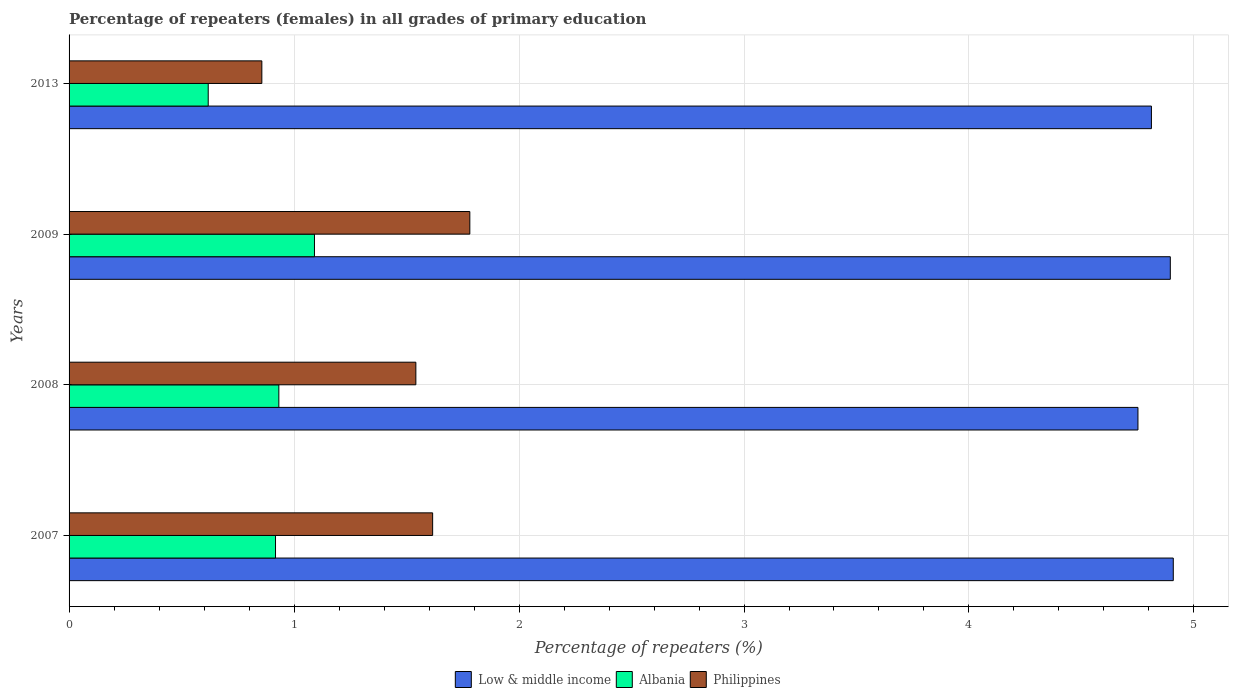How many groups of bars are there?
Provide a succinct answer. 4. How many bars are there on the 3rd tick from the top?
Offer a terse response. 3. How many bars are there on the 1st tick from the bottom?
Make the answer very short. 3. What is the percentage of repeaters (females) in Philippines in 2007?
Offer a very short reply. 1.62. Across all years, what is the maximum percentage of repeaters (females) in Low & middle income?
Provide a succinct answer. 4.91. Across all years, what is the minimum percentage of repeaters (females) in Low & middle income?
Provide a succinct answer. 4.75. In which year was the percentage of repeaters (females) in Philippines minimum?
Offer a terse response. 2013. What is the total percentage of repeaters (females) in Low & middle income in the graph?
Offer a terse response. 19.37. What is the difference between the percentage of repeaters (females) in Low & middle income in 2009 and that in 2013?
Provide a short and direct response. 0.08. What is the difference between the percentage of repeaters (females) in Philippines in 2007 and the percentage of repeaters (females) in Low & middle income in 2013?
Offer a very short reply. -3.19. What is the average percentage of repeaters (females) in Albania per year?
Provide a short and direct response. 0.89. In the year 2007, what is the difference between the percentage of repeaters (females) in Low & middle income and percentage of repeaters (females) in Philippines?
Make the answer very short. 3.29. What is the ratio of the percentage of repeaters (females) in Albania in 2007 to that in 2008?
Your answer should be compact. 0.98. Is the percentage of repeaters (females) in Albania in 2007 less than that in 2008?
Keep it short and to the point. Yes. What is the difference between the highest and the second highest percentage of repeaters (females) in Albania?
Make the answer very short. 0.16. What is the difference between the highest and the lowest percentage of repeaters (females) in Low & middle income?
Ensure brevity in your answer.  0.16. Is it the case that in every year, the sum of the percentage of repeaters (females) in Low & middle income and percentage of repeaters (females) in Albania is greater than the percentage of repeaters (females) in Philippines?
Offer a terse response. Yes. How many years are there in the graph?
Ensure brevity in your answer.  4. What is the difference between two consecutive major ticks on the X-axis?
Offer a very short reply. 1. Are the values on the major ticks of X-axis written in scientific E-notation?
Make the answer very short. No. Does the graph contain any zero values?
Provide a short and direct response. No. Where does the legend appear in the graph?
Provide a short and direct response. Bottom center. How many legend labels are there?
Your response must be concise. 3. How are the legend labels stacked?
Offer a terse response. Horizontal. What is the title of the graph?
Provide a succinct answer. Percentage of repeaters (females) in all grades of primary education. What is the label or title of the X-axis?
Give a very brief answer. Percentage of repeaters (%). What is the label or title of the Y-axis?
Offer a terse response. Years. What is the Percentage of repeaters (%) of Low & middle income in 2007?
Provide a succinct answer. 4.91. What is the Percentage of repeaters (%) in Albania in 2007?
Your answer should be very brief. 0.92. What is the Percentage of repeaters (%) in Philippines in 2007?
Offer a terse response. 1.62. What is the Percentage of repeaters (%) of Low & middle income in 2008?
Provide a succinct answer. 4.75. What is the Percentage of repeaters (%) of Albania in 2008?
Ensure brevity in your answer.  0.93. What is the Percentage of repeaters (%) of Philippines in 2008?
Make the answer very short. 1.54. What is the Percentage of repeaters (%) in Low & middle income in 2009?
Provide a succinct answer. 4.89. What is the Percentage of repeaters (%) in Albania in 2009?
Give a very brief answer. 1.09. What is the Percentage of repeaters (%) in Philippines in 2009?
Provide a short and direct response. 1.78. What is the Percentage of repeaters (%) in Low & middle income in 2013?
Offer a terse response. 4.81. What is the Percentage of repeaters (%) in Albania in 2013?
Offer a very short reply. 0.62. What is the Percentage of repeaters (%) of Philippines in 2013?
Offer a terse response. 0.86. Across all years, what is the maximum Percentage of repeaters (%) of Low & middle income?
Your answer should be very brief. 4.91. Across all years, what is the maximum Percentage of repeaters (%) in Albania?
Provide a succinct answer. 1.09. Across all years, what is the maximum Percentage of repeaters (%) of Philippines?
Provide a succinct answer. 1.78. Across all years, what is the minimum Percentage of repeaters (%) of Low & middle income?
Offer a terse response. 4.75. Across all years, what is the minimum Percentage of repeaters (%) in Albania?
Provide a succinct answer. 0.62. Across all years, what is the minimum Percentage of repeaters (%) in Philippines?
Keep it short and to the point. 0.86. What is the total Percentage of repeaters (%) of Low & middle income in the graph?
Provide a succinct answer. 19.37. What is the total Percentage of repeaters (%) of Albania in the graph?
Make the answer very short. 3.56. What is the total Percentage of repeaters (%) in Philippines in the graph?
Provide a short and direct response. 5.8. What is the difference between the Percentage of repeaters (%) in Low & middle income in 2007 and that in 2008?
Your answer should be very brief. 0.16. What is the difference between the Percentage of repeaters (%) in Albania in 2007 and that in 2008?
Provide a succinct answer. -0.01. What is the difference between the Percentage of repeaters (%) in Philippines in 2007 and that in 2008?
Provide a succinct answer. 0.07. What is the difference between the Percentage of repeaters (%) of Low & middle income in 2007 and that in 2009?
Provide a succinct answer. 0.01. What is the difference between the Percentage of repeaters (%) of Albania in 2007 and that in 2009?
Offer a very short reply. -0.17. What is the difference between the Percentage of repeaters (%) of Philippines in 2007 and that in 2009?
Your answer should be very brief. -0.17. What is the difference between the Percentage of repeaters (%) of Low & middle income in 2007 and that in 2013?
Make the answer very short. 0.1. What is the difference between the Percentage of repeaters (%) in Albania in 2007 and that in 2013?
Keep it short and to the point. 0.3. What is the difference between the Percentage of repeaters (%) in Philippines in 2007 and that in 2013?
Your answer should be very brief. 0.76. What is the difference between the Percentage of repeaters (%) of Low & middle income in 2008 and that in 2009?
Make the answer very short. -0.14. What is the difference between the Percentage of repeaters (%) in Albania in 2008 and that in 2009?
Give a very brief answer. -0.16. What is the difference between the Percentage of repeaters (%) in Philippines in 2008 and that in 2009?
Your answer should be very brief. -0.24. What is the difference between the Percentage of repeaters (%) in Low & middle income in 2008 and that in 2013?
Offer a very short reply. -0.06. What is the difference between the Percentage of repeaters (%) of Albania in 2008 and that in 2013?
Make the answer very short. 0.31. What is the difference between the Percentage of repeaters (%) of Philippines in 2008 and that in 2013?
Your answer should be very brief. 0.68. What is the difference between the Percentage of repeaters (%) in Low & middle income in 2009 and that in 2013?
Your response must be concise. 0.08. What is the difference between the Percentage of repeaters (%) of Albania in 2009 and that in 2013?
Your answer should be compact. 0.47. What is the difference between the Percentage of repeaters (%) in Philippines in 2009 and that in 2013?
Ensure brevity in your answer.  0.92. What is the difference between the Percentage of repeaters (%) of Low & middle income in 2007 and the Percentage of repeaters (%) of Albania in 2008?
Give a very brief answer. 3.98. What is the difference between the Percentage of repeaters (%) in Low & middle income in 2007 and the Percentage of repeaters (%) in Philippines in 2008?
Keep it short and to the point. 3.37. What is the difference between the Percentage of repeaters (%) in Albania in 2007 and the Percentage of repeaters (%) in Philippines in 2008?
Offer a very short reply. -0.62. What is the difference between the Percentage of repeaters (%) of Low & middle income in 2007 and the Percentage of repeaters (%) of Albania in 2009?
Offer a terse response. 3.82. What is the difference between the Percentage of repeaters (%) in Low & middle income in 2007 and the Percentage of repeaters (%) in Philippines in 2009?
Ensure brevity in your answer.  3.13. What is the difference between the Percentage of repeaters (%) in Albania in 2007 and the Percentage of repeaters (%) in Philippines in 2009?
Offer a terse response. -0.86. What is the difference between the Percentage of repeaters (%) in Low & middle income in 2007 and the Percentage of repeaters (%) in Albania in 2013?
Your response must be concise. 4.29. What is the difference between the Percentage of repeaters (%) in Low & middle income in 2007 and the Percentage of repeaters (%) in Philippines in 2013?
Give a very brief answer. 4.05. What is the difference between the Percentage of repeaters (%) of Albania in 2007 and the Percentage of repeaters (%) of Philippines in 2013?
Keep it short and to the point. 0.06. What is the difference between the Percentage of repeaters (%) of Low & middle income in 2008 and the Percentage of repeaters (%) of Albania in 2009?
Ensure brevity in your answer.  3.66. What is the difference between the Percentage of repeaters (%) of Low & middle income in 2008 and the Percentage of repeaters (%) of Philippines in 2009?
Make the answer very short. 2.97. What is the difference between the Percentage of repeaters (%) in Albania in 2008 and the Percentage of repeaters (%) in Philippines in 2009?
Make the answer very short. -0.85. What is the difference between the Percentage of repeaters (%) of Low & middle income in 2008 and the Percentage of repeaters (%) of Albania in 2013?
Provide a succinct answer. 4.13. What is the difference between the Percentage of repeaters (%) in Low & middle income in 2008 and the Percentage of repeaters (%) in Philippines in 2013?
Make the answer very short. 3.89. What is the difference between the Percentage of repeaters (%) in Albania in 2008 and the Percentage of repeaters (%) in Philippines in 2013?
Your answer should be compact. 0.08. What is the difference between the Percentage of repeaters (%) of Low & middle income in 2009 and the Percentage of repeaters (%) of Albania in 2013?
Make the answer very short. 4.28. What is the difference between the Percentage of repeaters (%) of Low & middle income in 2009 and the Percentage of repeaters (%) of Philippines in 2013?
Make the answer very short. 4.04. What is the difference between the Percentage of repeaters (%) of Albania in 2009 and the Percentage of repeaters (%) of Philippines in 2013?
Ensure brevity in your answer.  0.23. What is the average Percentage of repeaters (%) in Low & middle income per year?
Your response must be concise. 4.84. What is the average Percentage of repeaters (%) in Albania per year?
Your answer should be very brief. 0.89. What is the average Percentage of repeaters (%) in Philippines per year?
Your response must be concise. 1.45. In the year 2007, what is the difference between the Percentage of repeaters (%) in Low & middle income and Percentage of repeaters (%) in Albania?
Ensure brevity in your answer.  3.99. In the year 2007, what is the difference between the Percentage of repeaters (%) of Low & middle income and Percentage of repeaters (%) of Philippines?
Offer a very short reply. 3.29. In the year 2007, what is the difference between the Percentage of repeaters (%) in Albania and Percentage of repeaters (%) in Philippines?
Offer a terse response. -0.7. In the year 2008, what is the difference between the Percentage of repeaters (%) in Low & middle income and Percentage of repeaters (%) in Albania?
Your answer should be very brief. 3.82. In the year 2008, what is the difference between the Percentage of repeaters (%) in Low & middle income and Percentage of repeaters (%) in Philippines?
Offer a very short reply. 3.21. In the year 2008, what is the difference between the Percentage of repeaters (%) in Albania and Percentage of repeaters (%) in Philippines?
Offer a terse response. -0.61. In the year 2009, what is the difference between the Percentage of repeaters (%) in Low & middle income and Percentage of repeaters (%) in Albania?
Your answer should be very brief. 3.8. In the year 2009, what is the difference between the Percentage of repeaters (%) of Low & middle income and Percentage of repeaters (%) of Philippines?
Your answer should be compact. 3.11. In the year 2009, what is the difference between the Percentage of repeaters (%) in Albania and Percentage of repeaters (%) in Philippines?
Provide a short and direct response. -0.69. In the year 2013, what is the difference between the Percentage of repeaters (%) of Low & middle income and Percentage of repeaters (%) of Albania?
Offer a terse response. 4.19. In the year 2013, what is the difference between the Percentage of repeaters (%) of Low & middle income and Percentage of repeaters (%) of Philippines?
Make the answer very short. 3.95. In the year 2013, what is the difference between the Percentage of repeaters (%) of Albania and Percentage of repeaters (%) of Philippines?
Your answer should be compact. -0.24. What is the ratio of the Percentage of repeaters (%) in Low & middle income in 2007 to that in 2008?
Provide a short and direct response. 1.03. What is the ratio of the Percentage of repeaters (%) in Albania in 2007 to that in 2008?
Keep it short and to the point. 0.98. What is the ratio of the Percentage of repeaters (%) of Philippines in 2007 to that in 2008?
Ensure brevity in your answer.  1.05. What is the ratio of the Percentage of repeaters (%) in Low & middle income in 2007 to that in 2009?
Your answer should be very brief. 1. What is the ratio of the Percentage of repeaters (%) in Albania in 2007 to that in 2009?
Offer a terse response. 0.84. What is the ratio of the Percentage of repeaters (%) in Philippines in 2007 to that in 2009?
Provide a short and direct response. 0.91. What is the ratio of the Percentage of repeaters (%) in Low & middle income in 2007 to that in 2013?
Your answer should be very brief. 1.02. What is the ratio of the Percentage of repeaters (%) in Albania in 2007 to that in 2013?
Offer a very short reply. 1.48. What is the ratio of the Percentage of repeaters (%) of Philippines in 2007 to that in 2013?
Provide a succinct answer. 1.89. What is the ratio of the Percentage of repeaters (%) of Low & middle income in 2008 to that in 2009?
Keep it short and to the point. 0.97. What is the ratio of the Percentage of repeaters (%) of Albania in 2008 to that in 2009?
Your response must be concise. 0.85. What is the ratio of the Percentage of repeaters (%) of Philippines in 2008 to that in 2009?
Provide a short and direct response. 0.87. What is the ratio of the Percentage of repeaters (%) of Low & middle income in 2008 to that in 2013?
Offer a very short reply. 0.99. What is the ratio of the Percentage of repeaters (%) of Albania in 2008 to that in 2013?
Keep it short and to the point. 1.51. What is the ratio of the Percentage of repeaters (%) in Philippines in 2008 to that in 2013?
Make the answer very short. 1.8. What is the ratio of the Percentage of repeaters (%) in Low & middle income in 2009 to that in 2013?
Your answer should be very brief. 1.02. What is the ratio of the Percentage of repeaters (%) of Albania in 2009 to that in 2013?
Offer a very short reply. 1.76. What is the ratio of the Percentage of repeaters (%) in Philippines in 2009 to that in 2013?
Keep it short and to the point. 2.08. What is the difference between the highest and the second highest Percentage of repeaters (%) of Low & middle income?
Offer a very short reply. 0.01. What is the difference between the highest and the second highest Percentage of repeaters (%) in Albania?
Your answer should be very brief. 0.16. What is the difference between the highest and the second highest Percentage of repeaters (%) in Philippines?
Your answer should be very brief. 0.17. What is the difference between the highest and the lowest Percentage of repeaters (%) in Low & middle income?
Provide a succinct answer. 0.16. What is the difference between the highest and the lowest Percentage of repeaters (%) of Albania?
Offer a very short reply. 0.47. What is the difference between the highest and the lowest Percentage of repeaters (%) of Philippines?
Offer a very short reply. 0.92. 